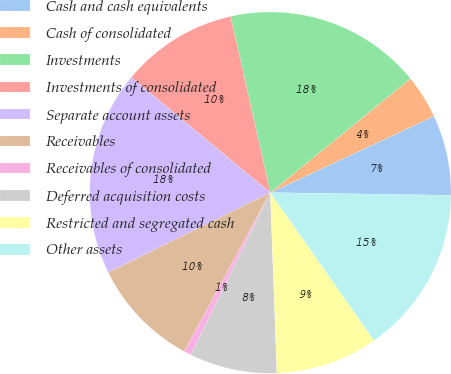Convert chart. <chart><loc_0><loc_0><loc_500><loc_500><pie_chart><fcel>Cash and cash equivalents<fcel>Cash of consolidated<fcel>Investments<fcel>Investments of consolidated<fcel>Separate account assets<fcel>Receivables<fcel>Receivables of consolidated<fcel>Deferred acquisition costs<fcel>Restricted and segregated cash<fcel>Other assets<nl><fcel>7.19%<fcel>3.92%<fcel>17.65%<fcel>10.46%<fcel>18.3%<fcel>9.8%<fcel>0.65%<fcel>7.84%<fcel>9.15%<fcel>15.03%<nl></chart> 